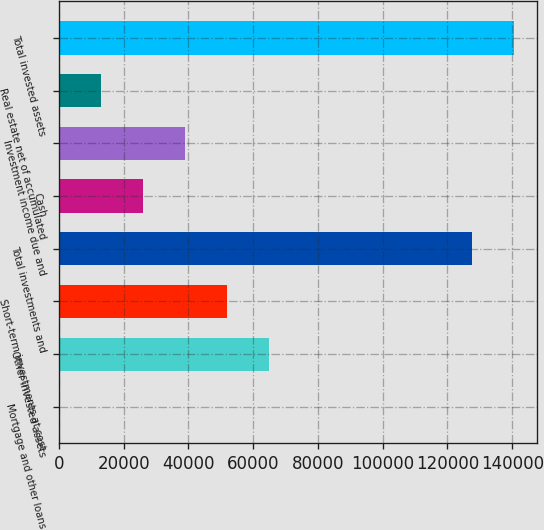Convert chart to OTSL. <chart><loc_0><loc_0><loc_500><loc_500><bar_chart><fcel>Mortgage and other loans<fcel>Other invested assets<fcel>Short-term investments at cost<fcel>Total investments and<fcel>Cash<fcel>Investment income due and<fcel>Real estate net of accumulated<fcel>Total invested assets<nl><fcel>13<fcel>64901<fcel>51923.4<fcel>127512<fcel>25968.2<fcel>38945.8<fcel>12990.6<fcel>140490<nl></chart> 